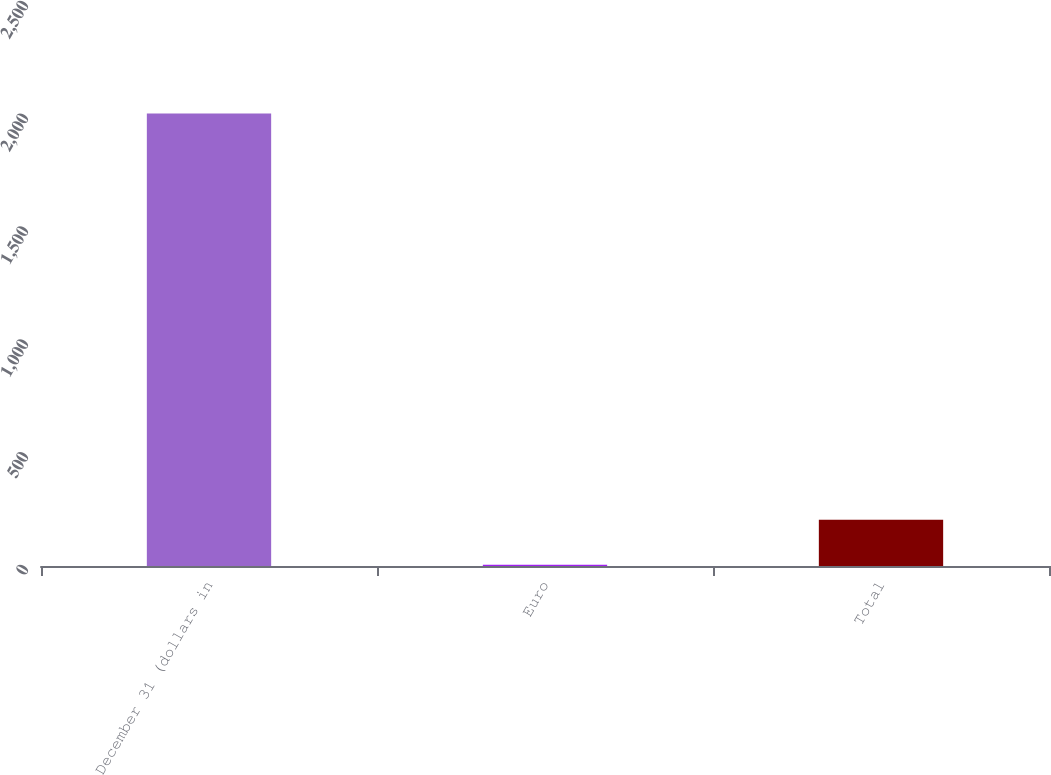<chart> <loc_0><loc_0><loc_500><loc_500><bar_chart><fcel>December 31 (dollars in<fcel>Euro<fcel>Total<nl><fcel>2006<fcel>5.4<fcel>205.46<nl></chart> 